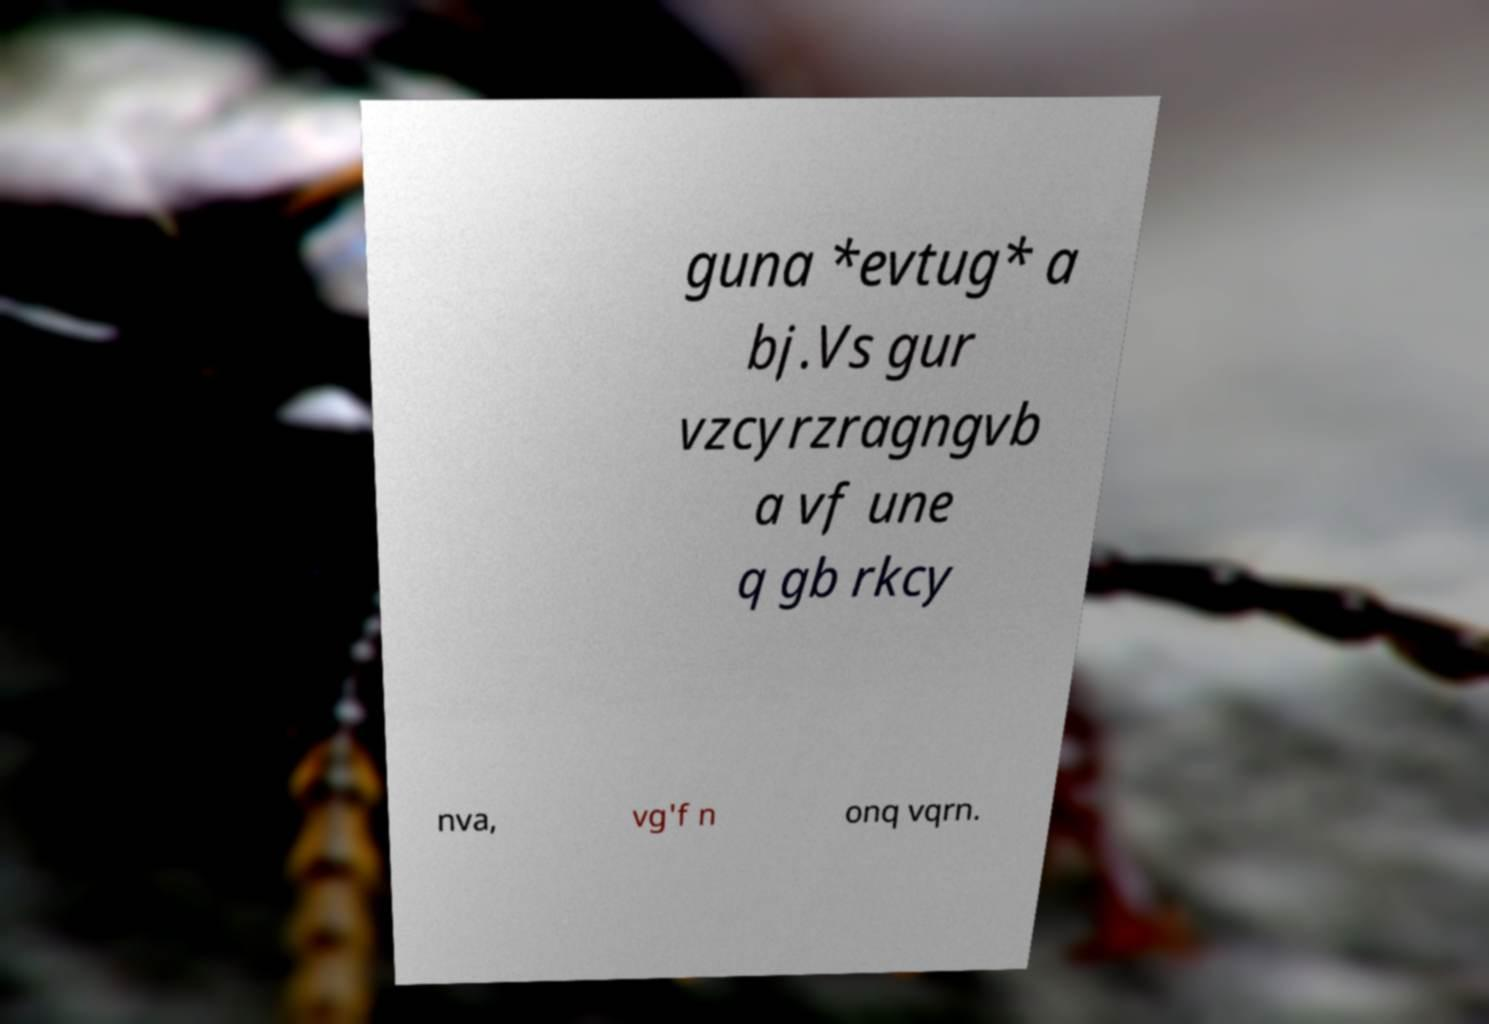What messages or text are displayed in this image? I need them in a readable, typed format. guna *evtug* a bj.Vs gur vzcyrzragngvb a vf une q gb rkcy nva, vg'f n onq vqrn. 